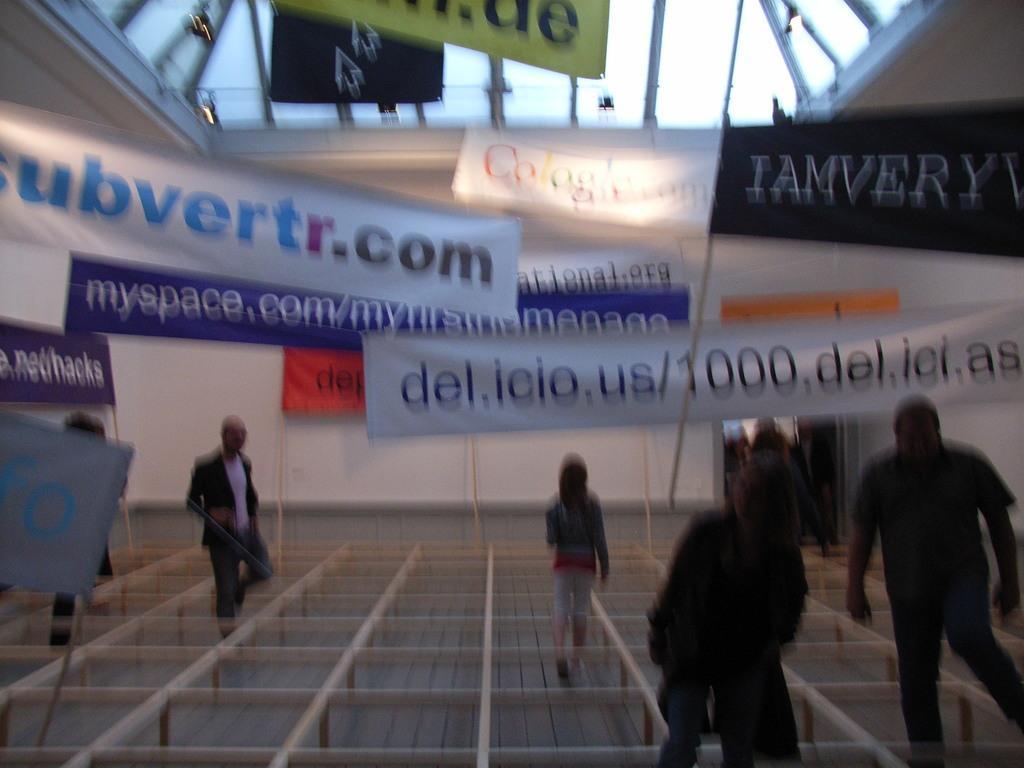In one or two sentences, can you explain what this image depicts? In the image there are blocks made with wooden sticks and people are moving through those boxes and around them there are a lot of banners. 